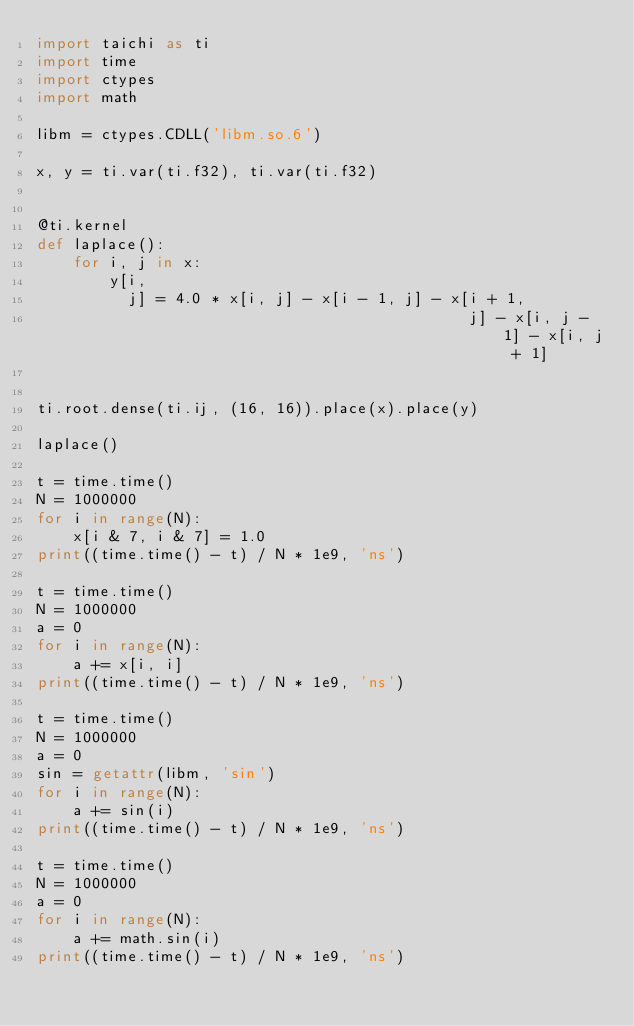<code> <loc_0><loc_0><loc_500><loc_500><_Python_>import taichi as ti
import time
import ctypes
import math

libm = ctypes.CDLL('libm.so.6')

x, y = ti.var(ti.f32), ti.var(ti.f32)


@ti.kernel
def laplace():
    for i, j in x:
        y[i,
          j] = 4.0 * x[i, j] - x[i - 1, j] - x[i + 1,
                                               j] - x[i, j - 1] - x[i, j + 1]


ti.root.dense(ti.ij, (16, 16)).place(x).place(y)

laplace()

t = time.time()
N = 1000000
for i in range(N):
    x[i & 7, i & 7] = 1.0
print((time.time() - t) / N * 1e9, 'ns')

t = time.time()
N = 1000000
a = 0
for i in range(N):
    a += x[i, i]
print((time.time() - t) / N * 1e9, 'ns')

t = time.time()
N = 1000000
a = 0
sin = getattr(libm, 'sin')
for i in range(N):
    a += sin(i)
print((time.time() - t) / N * 1e9, 'ns')

t = time.time()
N = 1000000
a = 0
for i in range(N):
    a += math.sin(i)
print((time.time() - t) / N * 1e9, 'ns')
</code> 